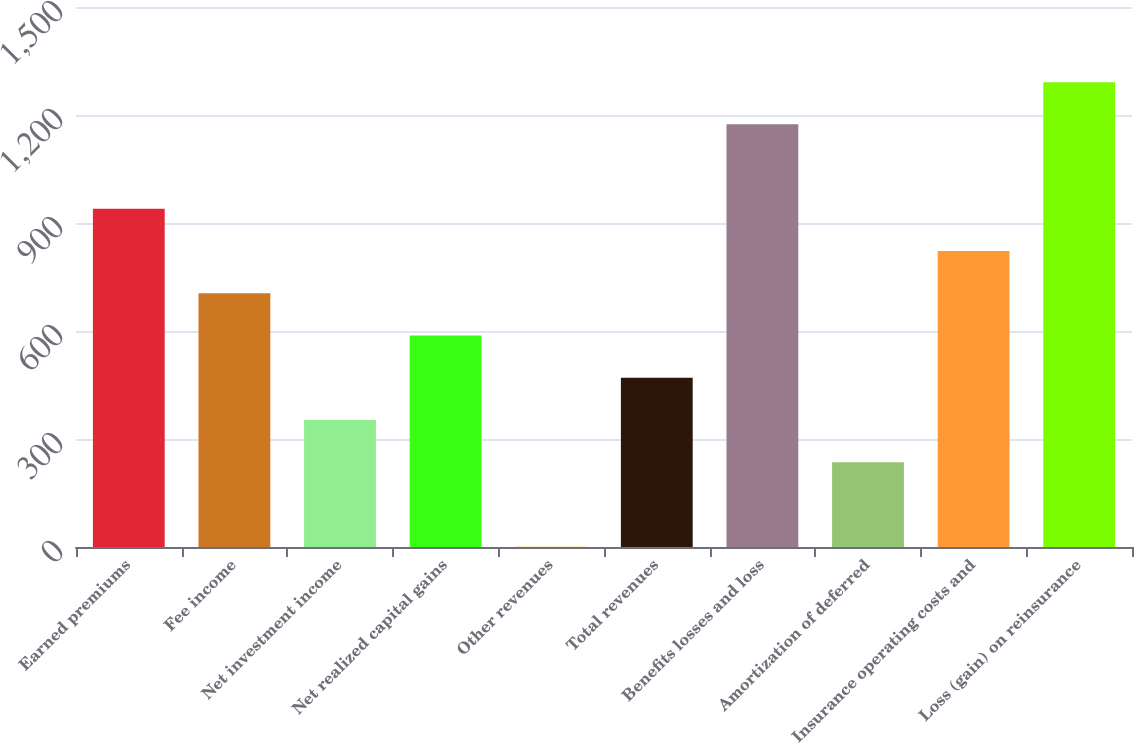<chart> <loc_0><loc_0><loc_500><loc_500><bar_chart><fcel>Earned premiums<fcel>Fee income<fcel>Net investment income<fcel>Net realized capital gains<fcel>Other revenues<fcel>Total revenues<fcel>Benefits losses and loss<fcel>Amortization of deferred<fcel>Insurance operating costs and<fcel>Loss (gain) on reinsurance<nl><fcel>939.4<fcel>704.8<fcel>352.9<fcel>587.5<fcel>1<fcel>470.2<fcel>1174<fcel>235.6<fcel>822.1<fcel>1291.3<nl></chart> 